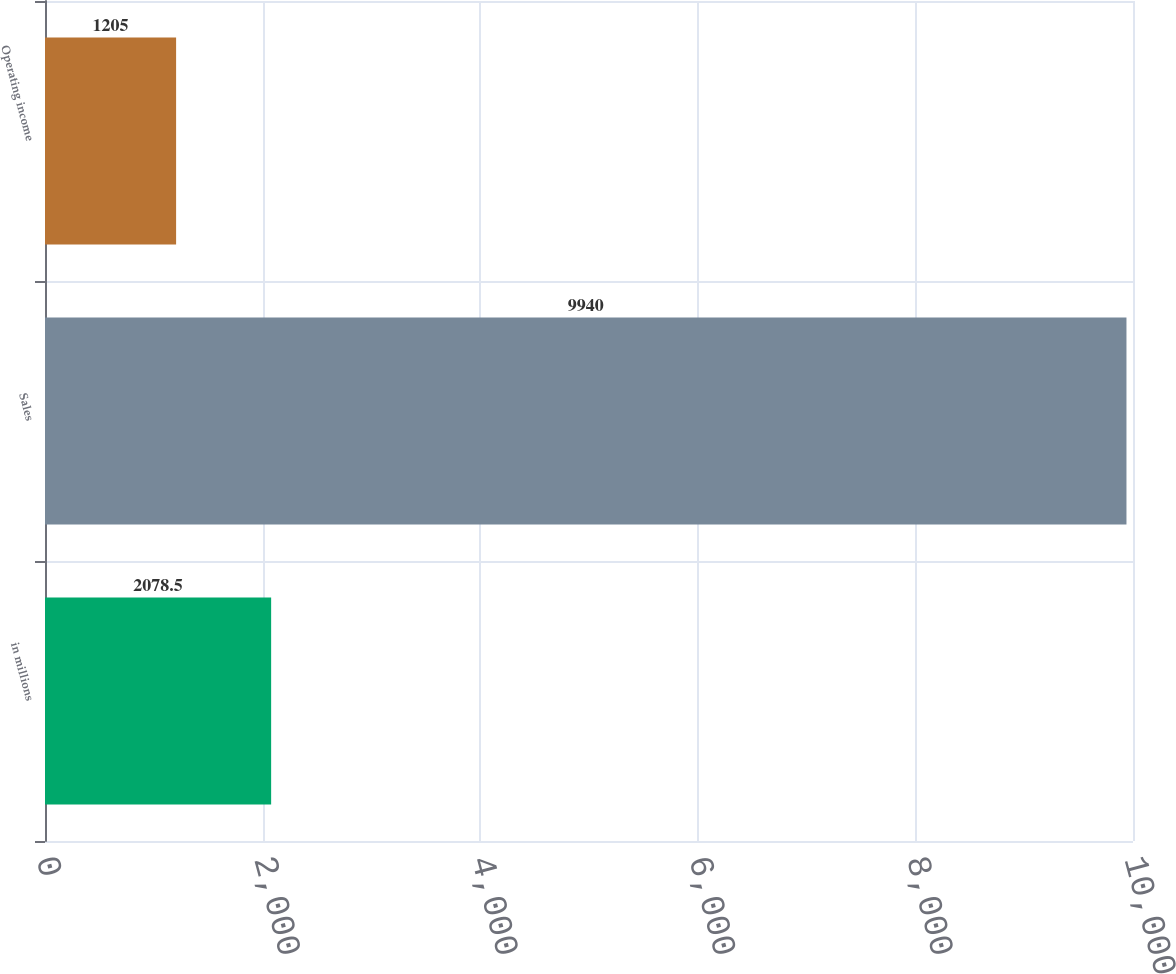Convert chart to OTSL. <chart><loc_0><loc_0><loc_500><loc_500><bar_chart><fcel>in millions<fcel>Sales<fcel>Operating income<nl><fcel>2078.5<fcel>9940<fcel>1205<nl></chart> 